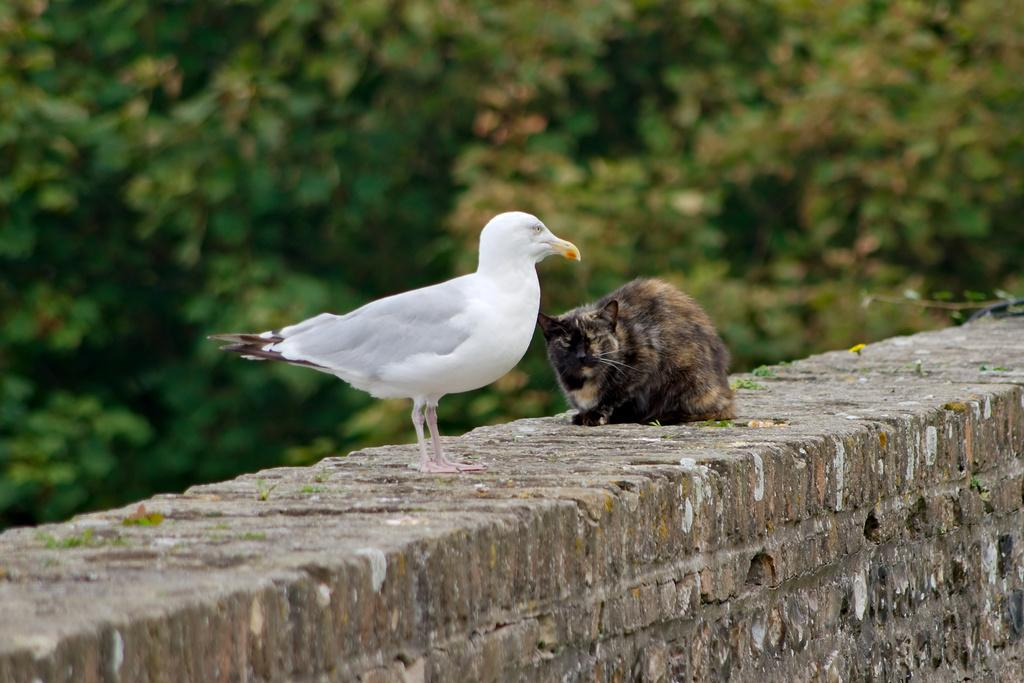What type of animal can be seen in the image? There is a bird in the image. What other animal is present in the image? There is a cat in the image. Where are the bird and the cat located in the image? Both the bird and the cat are on a wall. What can be seen in the background of the image? There are leaves visible in the background of the image. What type of whip is the bird using to scare the cat in the image? There is no whip present in the image, and the bird is not using any object to scare the cat. 